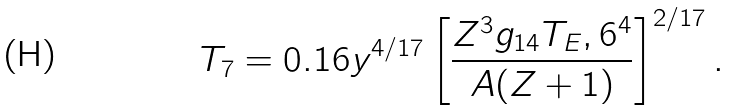<formula> <loc_0><loc_0><loc_500><loc_500>T _ { 7 } = 0 . 1 6 y ^ { 4 / 1 7 } \left [ \frac { Z ^ { 3 } g _ { 1 4 } T _ { E } , 6 ^ { 4 } } { A ( Z + 1 ) } \right ] ^ { 2 / 1 7 } .</formula> 